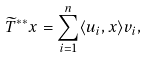Convert formula to latex. <formula><loc_0><loc_0><loc_500><loc_500>\widetilde { T } ^ { * * } x = \sum _ { i = 1 } ^ { n } \langle u _ { i } , x \rangle v _ { i } ,</formula> 